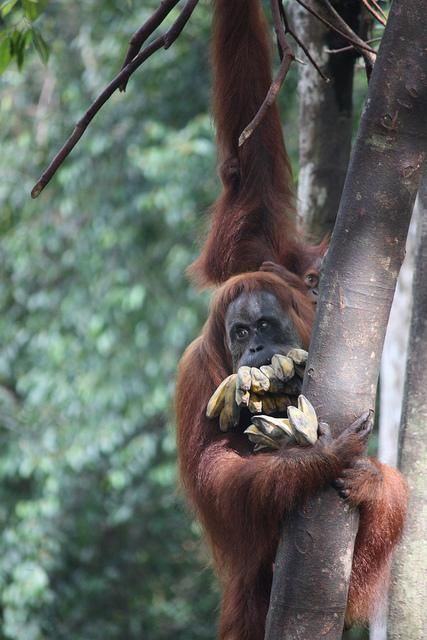What kind of fruit does the orangutan have in its mouth?

Choices:
A) watermelon
B) bananas
C) apples
D) oranges bananas 